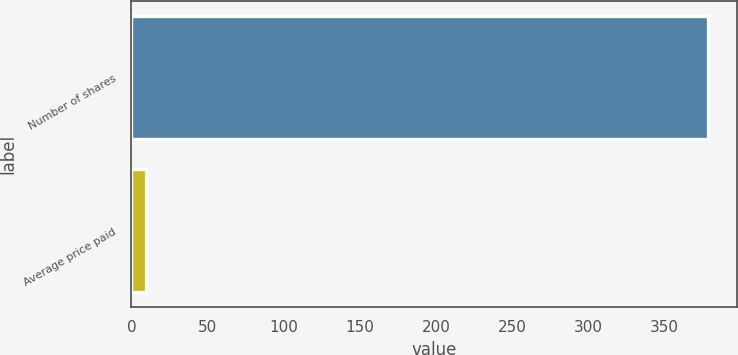Convert chart to OTSL. <chart><loc_0><loc_0><loc_500><loc_500><bar_chart><fcel>Number of shares<fcel>Average price paid<nl><fcel>379<fcel>9.49<nl></chart> 